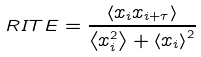<formula> <loc_0><loc_0><loc_500><loc_500>R I T E = \frac { \left \langle x _ { i } x _ { i + \tau } \right \rangle } { \left \langle x _ { i } ^ { 2 } \right \rangle + \left \langle x _ { i } \right \rangle ^ { 2 } }</formula> 